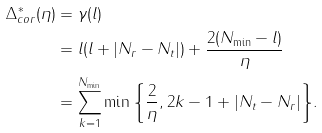<formula> <loc_0><loc_0><loc_500><loc_500>\Delta ^ { * } _ { c o r } ( \eta ) & = \gamma ( l ) \\ & = l ( l + | N _ { r } - N _ { t } | ) + \frac { 2 ( N _ { \min } - l ) } { \eta } \\ & = \sum _ { k = 1 } ^ { N _ { \min } } { \min \left \{ \frac { 2 } { \eta } , 2 k - 1 + | N _ { t } - N _ { r } | \right \} } .</formula> 